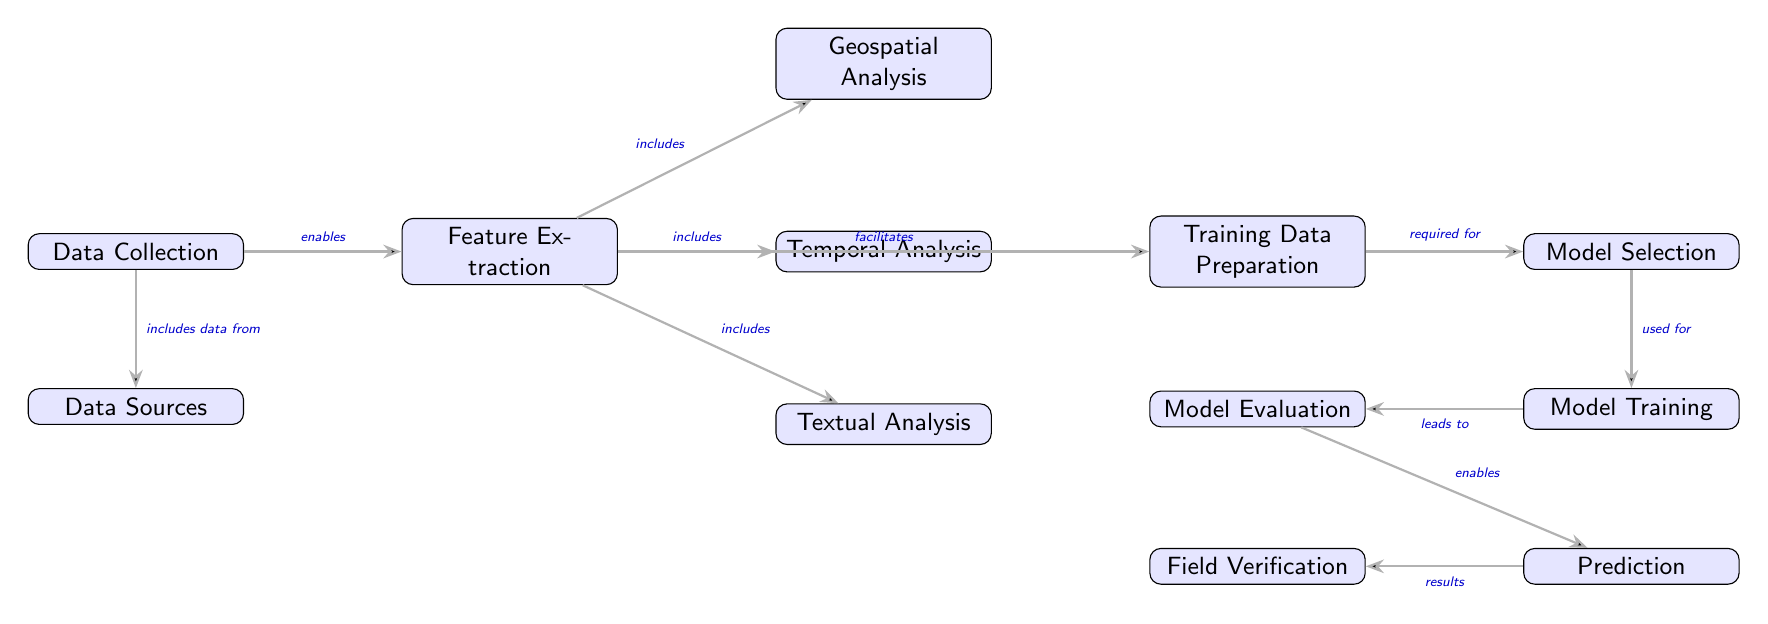What is the first step in the predictive modeling process? The first step in the diagram is "Data Collection," which is the initial phase before any other analysis can take place.
Answer: Data Collection How many nodes are there in total in the diagram? By counting all the displayed nodes in the diagram, we find that there are twelve nodes reflecting different components of the predictive modeling process.
Answer: Twelve Which node provides the final output of the process? The final output of the process is indicated in the "Field Verification" node, which occurs after the prediction stage.
Answer: Field Verification What type of analysis is included that focuses on the geographical aspects of manuscript recovery? The node that focuses on the geographical aspects is "Geospatial Analysis," which is one of the analyses extracted from the data during the feature extraction phase.
Answer: Geospatial Analysis Which node is directly connected to "Model Evaluation"? The "Model Training" node is directly connected to "Model Evaluation," indicating it is the preceding step necessary before evaluation can take place.
Answer: Model Training What is the primary action taken after "Model Selection"? After "Model Selection," the primary action taken is "Model Training," which develops the model based on selected parameters.
Answer: Model Training Which analysis type is specifically aimed at understanding the content of texts? The node dedicated to understanding the content of texts is "Textual Analysis," which explores the features of the manuscripts.
Answer: Textual Analysis How does "Data Collection" relate to "Data Sources"? "Data Collection" includes data from "Data Sources," meaning it gathers information from various referenced sources for further processing.
Answer: includes data from What is the role of "Training Data Preparation" in the context of model selection? The role of "Training Data Preparation" is to provide the necessary data that is required for "Model Selection," ensuring that the model can be accurately chosen based on prepared datasets.
Answer: required for Which node follows "Model Training" in the sequence? The node that follows "Model Training" is "Model Evaluation," indicating the next step after the model has been developed.
Answer: Model Evaluation 